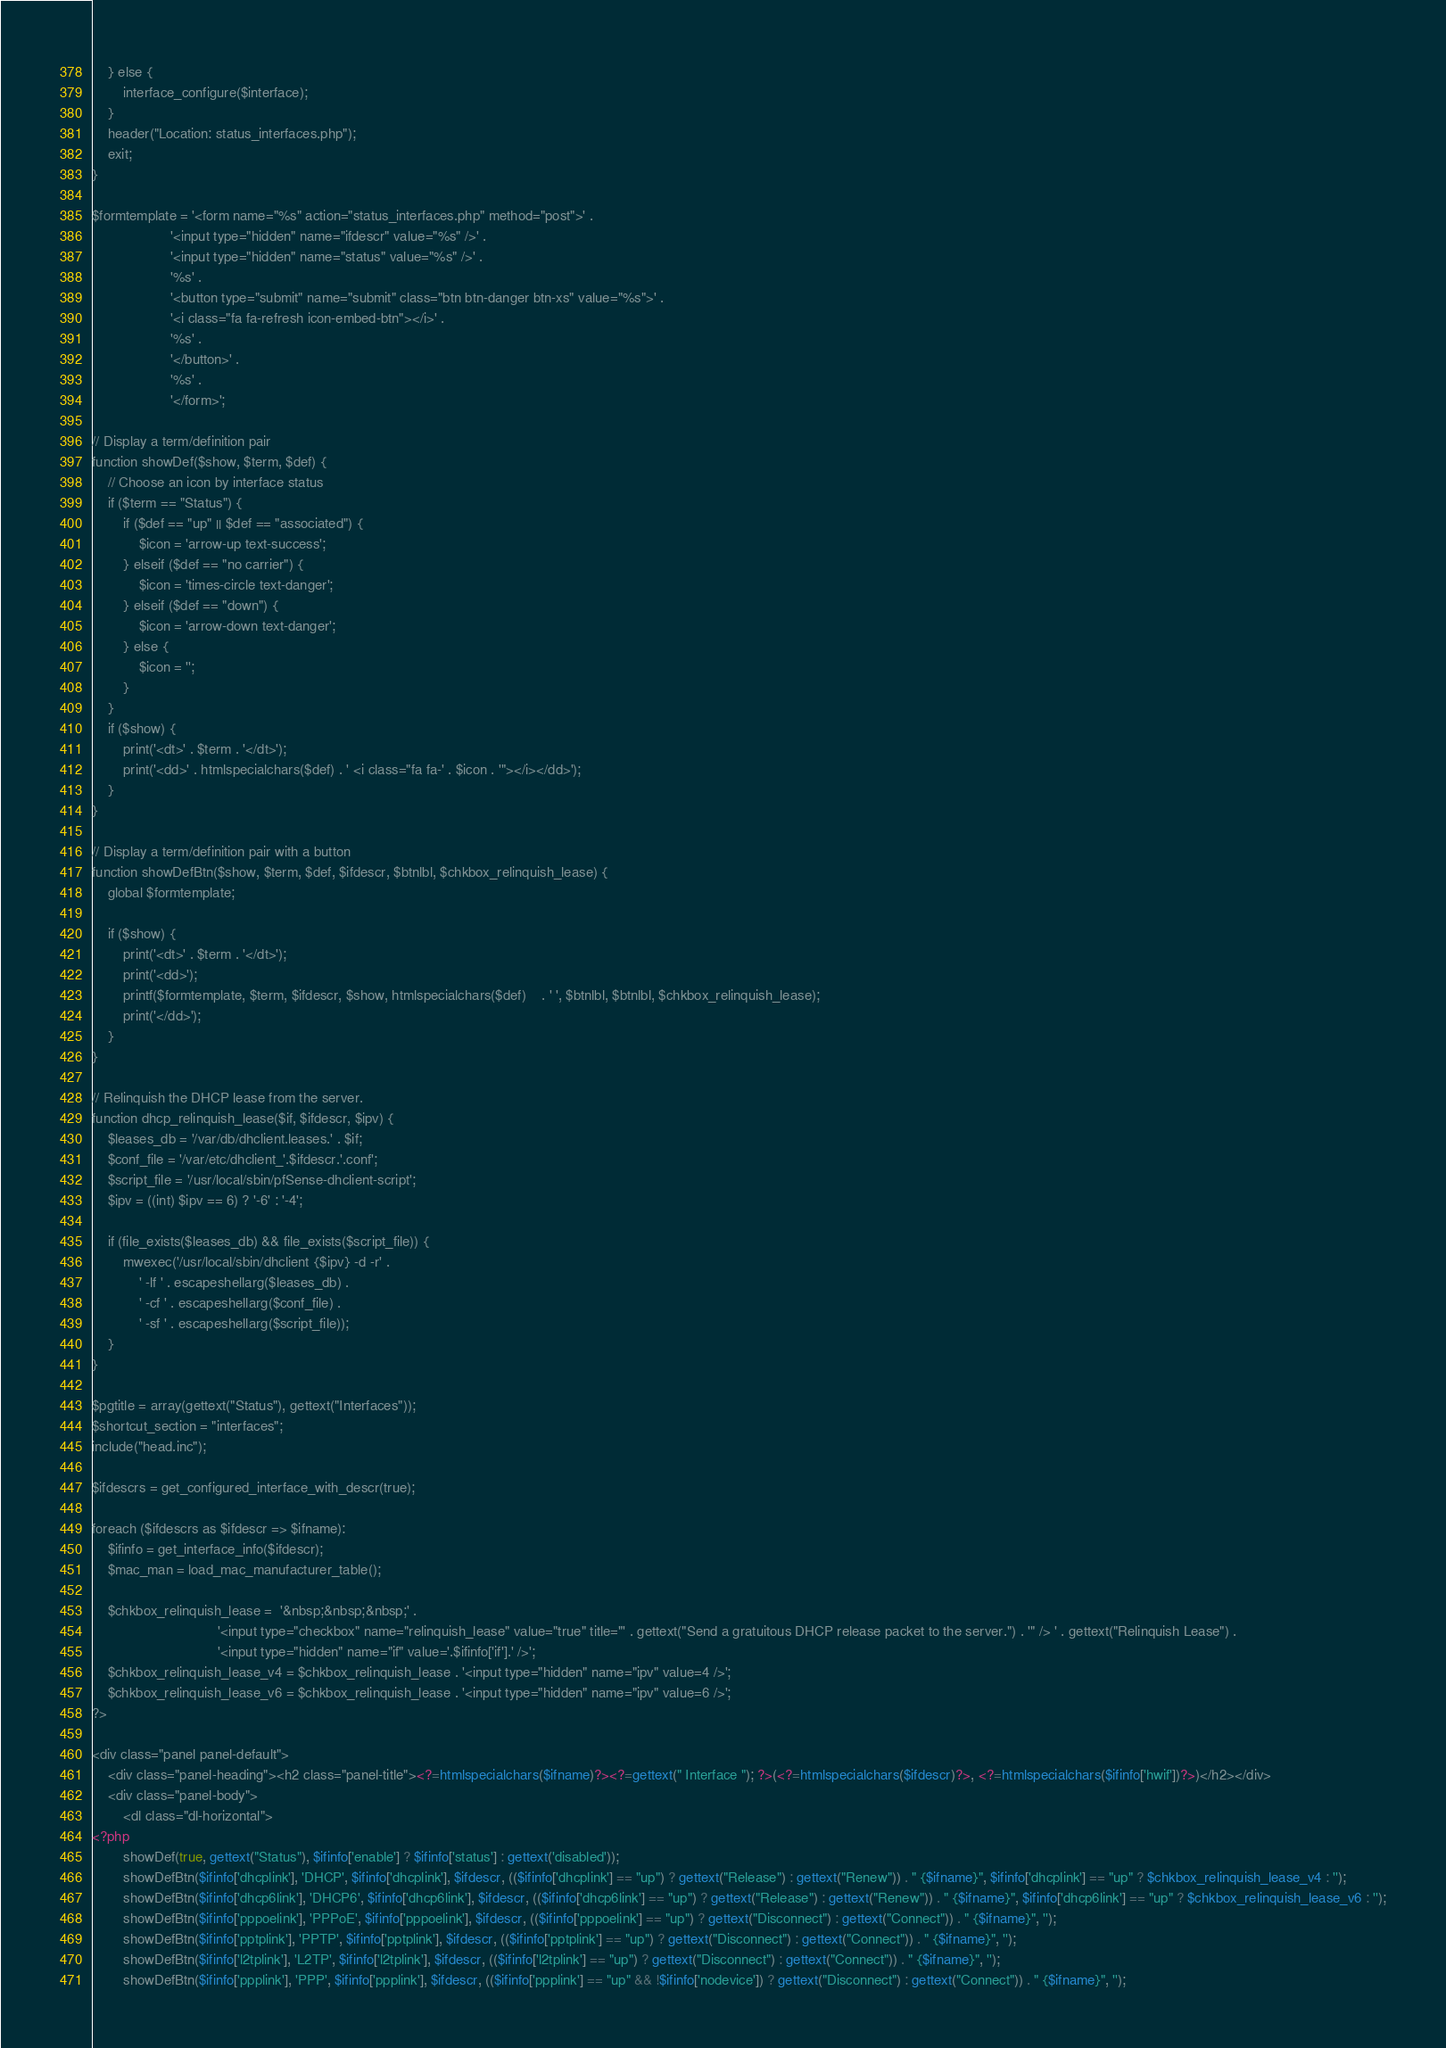Convert code to text. <code><loc_0><loc_0><loc_500><loc_500><_PHP_>	} else {
		interface_configure($interface);
	}
	header("Location: status_interfaces.php");
	exit;
}

$formtemplate = '<form name="%s" action="status_interfaces.php" method="post">' .
					'<input type="hidden" name="ifdescr" value="%s" />' .
					'<input type="hidden" name="status" value="%s" />' .
					'%s' .
					'<button type="submit" name="submit" class="btn btn-danger btn-xs" value="%s">' .
					'<i class="fa fa-refresh icon-embed-btn"></i>' .
					'%s' .
					'</button>' .
					'%s' .
					'</form>';

// Display a term/definition pair
function showDef($show, $term, $def) {
	// Choose an icon by interface status
	if ($term == "Status") {
		if ($def == "up" || $def == "associated") {
			$icon = 'arrow-up text-success';
		} elseif ($def == "no carrier") {
			$icon = 'times-circle text-danger';
		} elseif ($def == "down") {
			$icon = 'arrow-down text-danger';
		} else {
			$icon = '';
		}
	}
	if ($show) {
		print('<dt>' . $term . '</dt>');
		print('<dd>' . htmlspecialchars($def) . ' <i class="fa fa-' . $icon . '"></i></dd>');
	}
}

// Display a term/definition pair with a button
function showDefBtn($show, $term, $def, $ifdescr, $btnlbl, $chkbox_relinquish_lease) {
	global $formtemplate;

	if ($show) {
		print('<dt>' . $term . '</dt>');
		print('<dd>');
		printf($formtemplate, $term, $ifdescr, $show, htmlspecialchars($def)	. ' ', $btnlbl, $btnlbl, $chkbox_relinquish_lease);
		print('</dd>');
	}
}

// Relinquish the DHCP lease from the server.
function dhcp_relinquish_lease($if, $ifdescr, $ipv) {
	$leases_db = '/var/db/dhclient.leases.' . $if;
	$conf_file = '/var/etc/dhclient_'.$ifdescr.'.conf';
	$script_file = '/usr/local/sbin/pfSense-dhclient-script';
	$ipv = ((int) $ipv == 6) ? '-6' : '-4';

	if (file_exists($leases_db) && file_exists($script_file)) {
		mwexec('/usr/local/sbin/dhclient {$ipv} -d -r' .
			' -lf ' . escapeshellarg($leases_db) .
			' -cf ' . escapeshellarg($conf_file) .
			' -sf ' . escapeshellarg($script_file));
	}
}

$pgtitle = array(gettext("Status"), gettext("Interfaces"));
$shortcut_section = "interfaces";
include("head.inc");

$ifdescrs = get_configured_interface_with_descr(true);

foreach ($ifdescrs as $ifdescr => $ifname):
	$ifinfo = get_interface_info($ifdescr);
	$mac_man = load_mac_manufacturer_table();

	$chkbox_relinquish_lease = 	'&nbsp;&nbsp;&nbsp;' .
								'<input type="checkbox" name="relinquish_lease" value="true" title="' . gettext("Send a gratuitous DHCP release packet to the server.") . '" /> ' . gettext("Relinquish Lease") .
								'<input type="hidden" name="if" value='.$ifinfo['if'].' />';
	$chkbox_relinquish_lease_v4 = $chkbox_relinquish_lease . '<input type="hidden" name="ipv" value=4 />';
	$chkbox_relinquish_lease_v6 = $chkbox_relinquish_lease . '<input type="hidden" name="ipv" value=6 />';
?>

<div class="panel panel-default">
	<div class="panel-heading"><h2 class="panel-title"><?=htmlspecialchars($ifname)?><?=gettext(" Interface "); ?>(<?=htmlspecialchars($ifdescr)?>, <?=htmlspecialchars($ifinfo['hwif'])?>)</h2></div>
	<div class="panel-body">
		<dl class="dl-horizontal">
<?php
		showDef(true, gettext("Status"), $ifinfo['enable'] ? $ifinfo['status'] : gettext('disabled'));
		showDefBtn($ifinfo['dhcplink'], 'DHCP', $ifinfo['dhcplink'], $ifdescr, (($ifinfo['dhcplink'] == "up") ? gettext("Release") : gettext("Renew")) . " {$ifname}", $ifinfo['dhcplink'] == "up" ? $chkbox_relinquish_lease_v4 : '');
		showDefBtn($ifinfo['dhcp6link'], 'DHCP6', $ifinfo['dhcp6link'], $ifdescr, (($ifinfo['dhcp6link'] == "up") ? gettext("Release") : gettext("Renew")) . " {$ifname}", $ifinfo['dhcp6link'] == "up" ? $chkbox_relinquish_lease_v6 : '');
		showDefBtn($ifinfo['pppoelink'], 'PPPoE', $ifinfo['pppoelink'], $ifdescr, (($ifinfo['pppoelink'] == "up") ? gettext("Disconnect") : gettext("Connect")) . " {$ifname}", '');
		showDefBtn($ifinfo['pptplink'], 'PPTP', $ifinfo['pptplink'], $ifdescr, (($ifinfo['pptplink'] == "up") ? gettext("Disconnect") : gettext("Connect")) . " {$ifname}", '');
		showDefBtn($ifinfo['l2tplink'], 'L2TP', $ifinfo['l2tplink'], $ifdescr, (($ifinfo['l2tplink'] == "up") ? gettext("Disconnect") : gettext("Connect")) . " {$ifname}", '');
		showDefBtn($ifinfo['ppplink'], 'PPP', $ifinfo['ppplink'], $ifdescr, (($ifinfo['ppplink'] == "up" && !$ifinfo['nodevice']) ? gettext("Disconnect") : gettext("Connect")) . " {$ifname}", '');</code> 